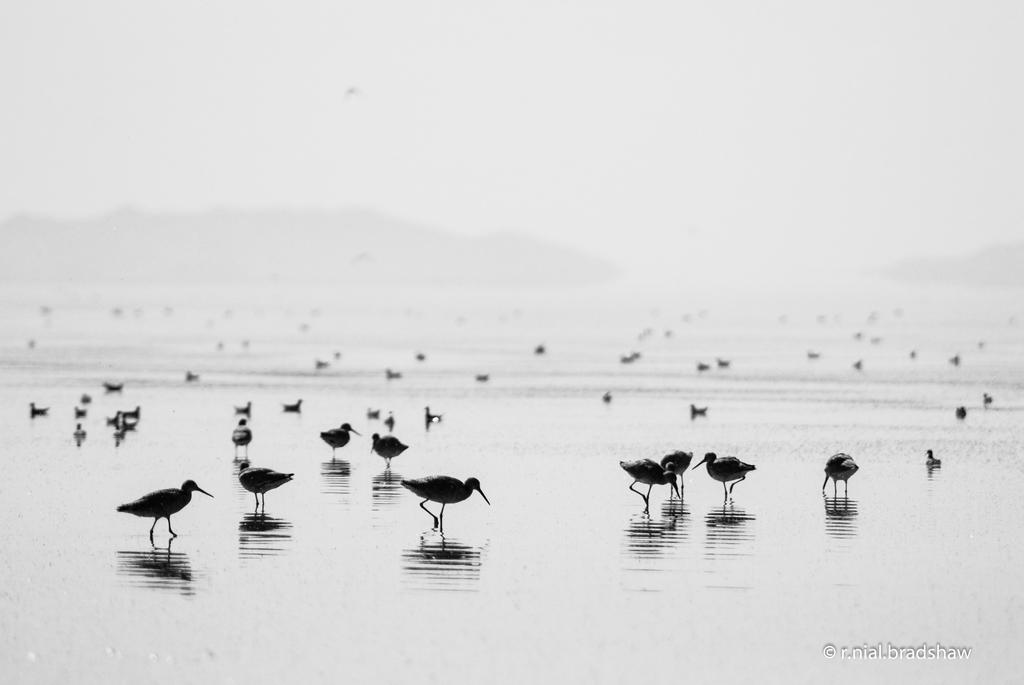Can you describe this image briefly? In this picture we can see birds on the ground. Background portion of the picture is blurry and it seems like hills. In the bottom right corner of the picture we can see a water mark. 